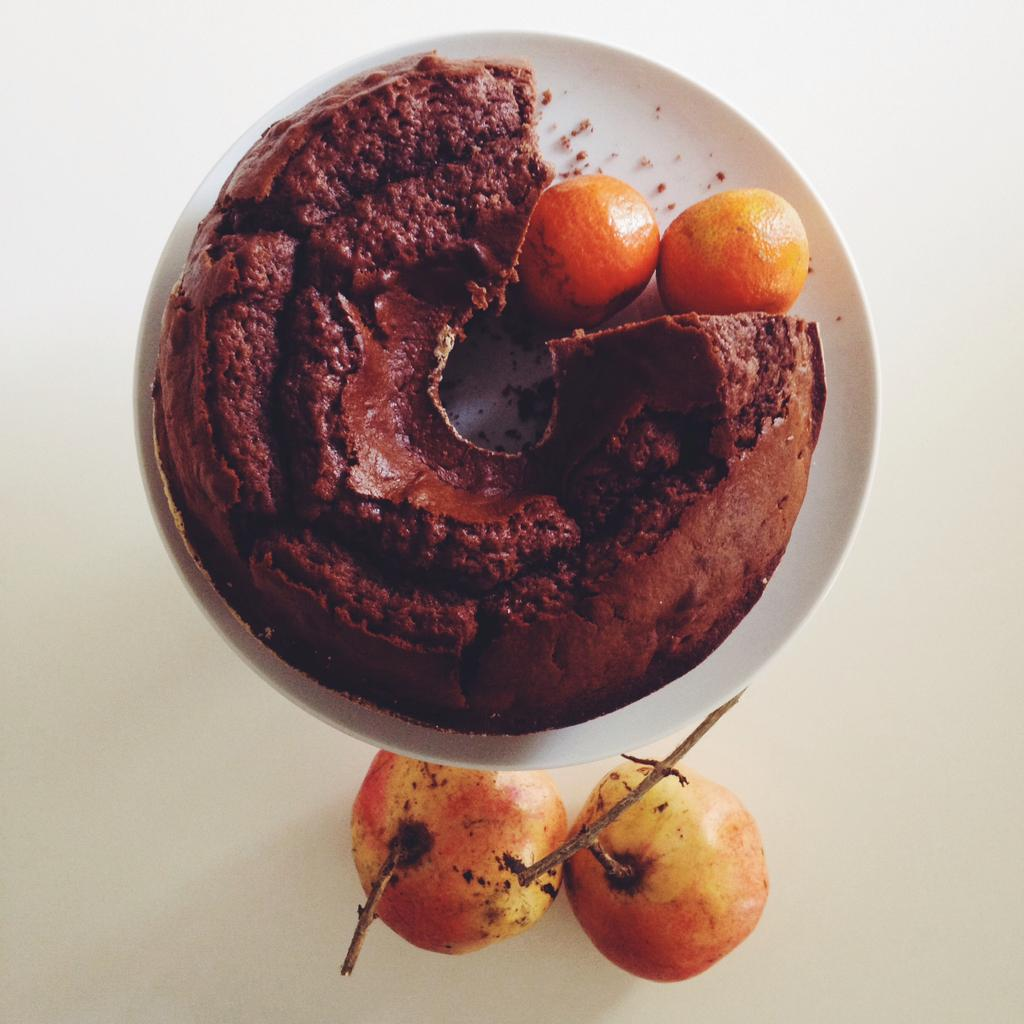What is located in the center of the image? There is a table in the center of the image. What is placed on the table? There is a plate on the table. What types of food are on the plate? There are fruits and a cake on the plate. Which specific fruit can be seen on the plate? There are oranges in the plate. What is the room number of the room where the image was taken? The provided facts do not mention a room or a room number, so it cannot be determined from the image. 